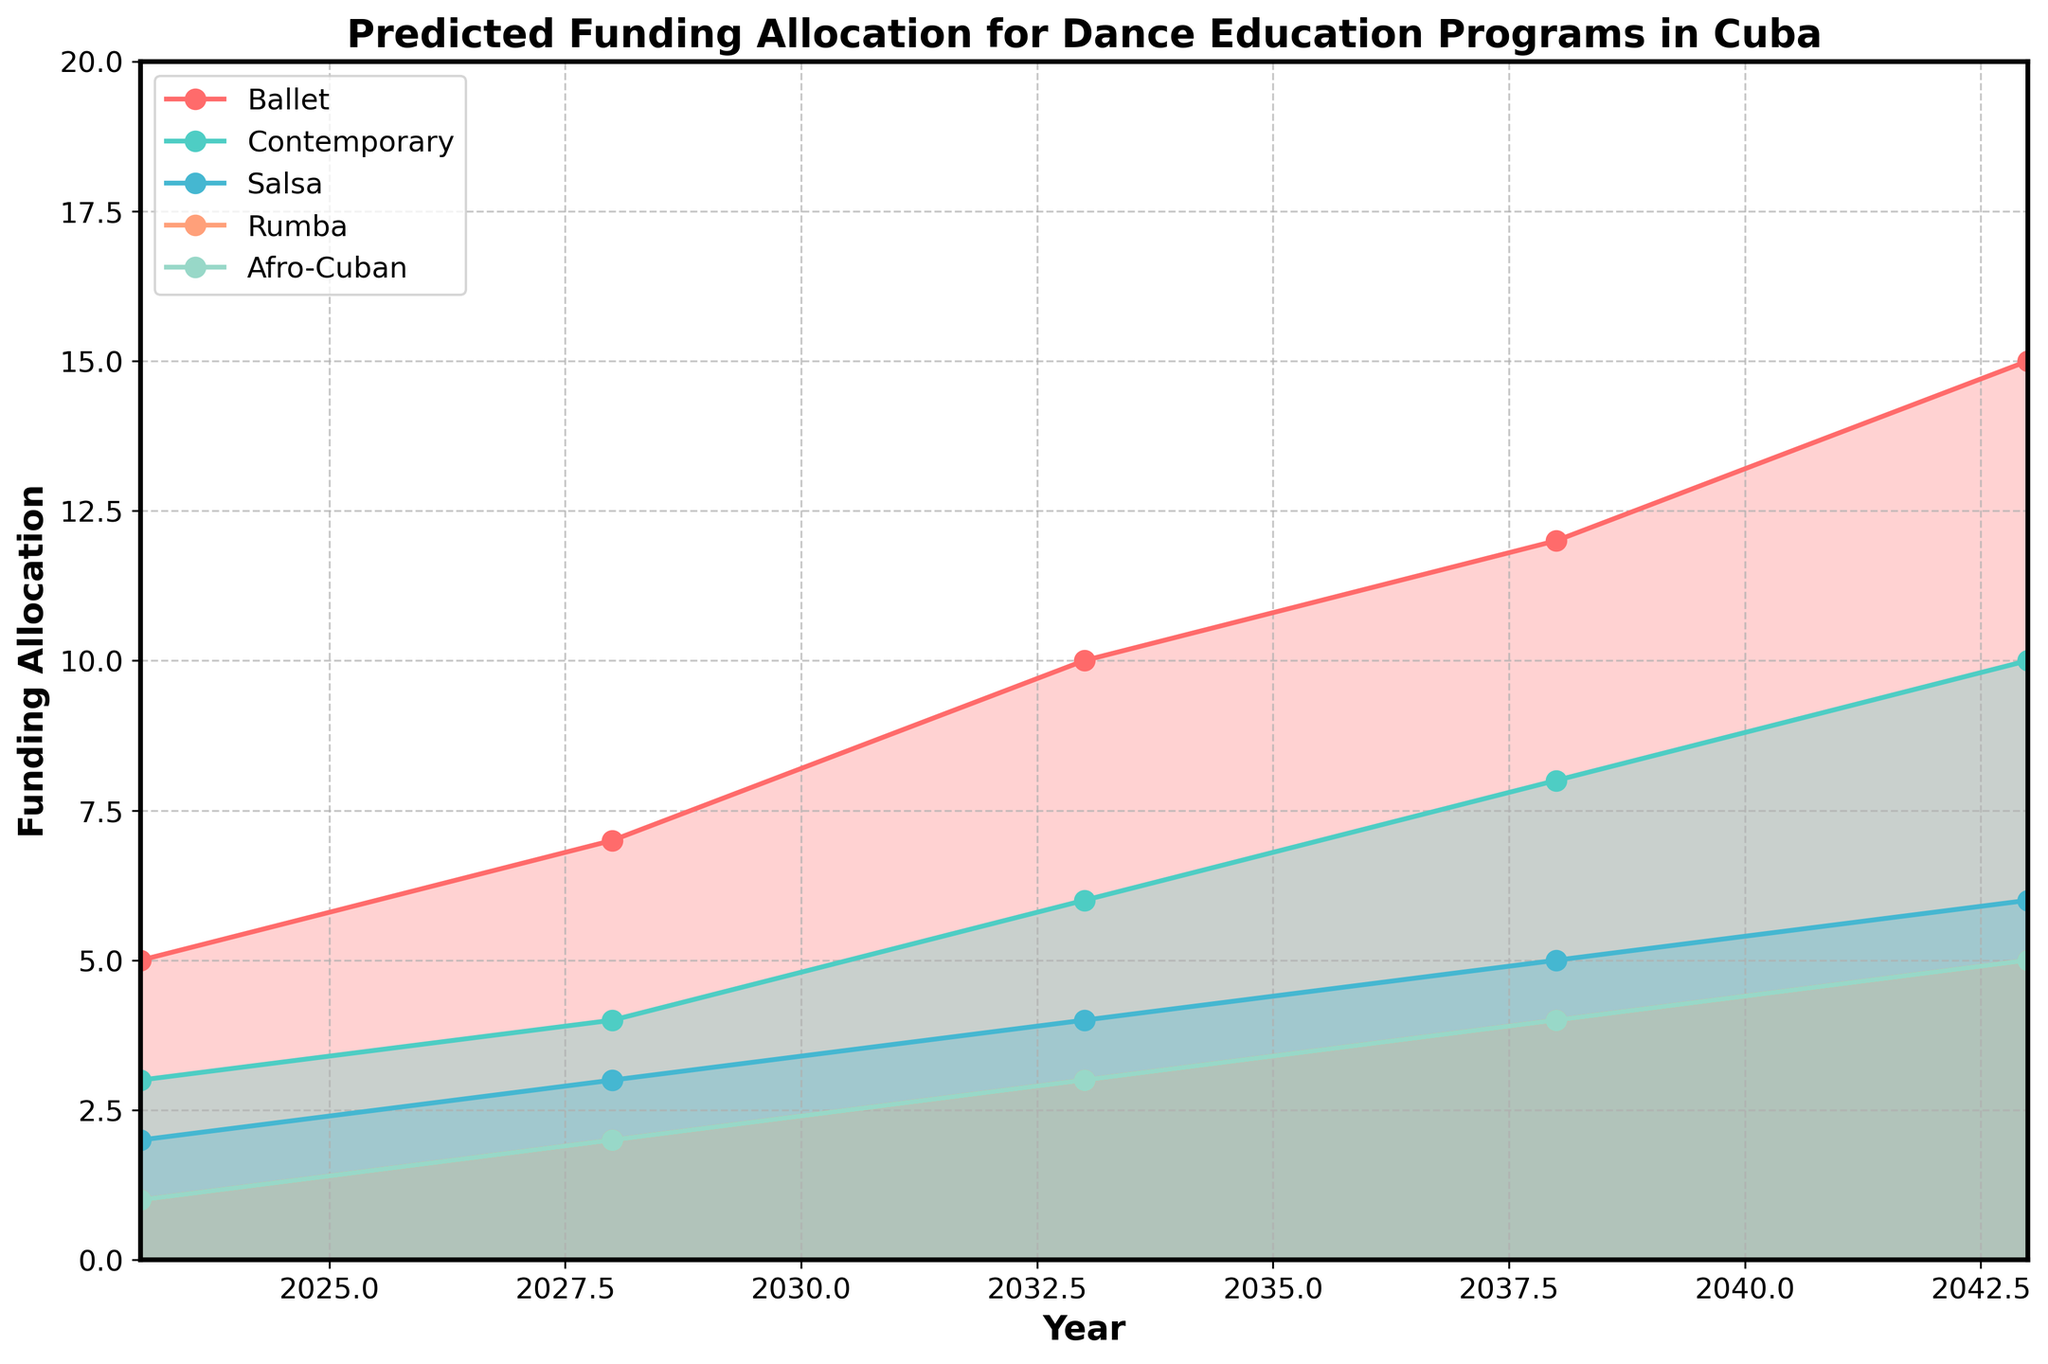What is the title of the figure? The title is usually displayed at the top of the figure. For this particular plot, the title should describe the content and focus of the chart.
Answer: Predicted Funding Allocation for Dance Education Programs in Cuba Which dance style shows the highest predicted funding in 2043? By looking at the endpoint for each line in the year 2043, we can determine which dance style has the highest value.
Answer: Ballet What is the predicted funding allocation for Afro-Cuban dance in the year 2033? To find the value, locate the year 2033 on the x-axis and follow the line corresponding to Afro-Cuban dance to the y-axis.
Answer: 3 How does the funding allocation for Contemporary dance in 2028 compare to Salsa in the same year? Find the values for Contemporary dance and Salsa in the year 2028. Contemporary is 4, Salsa is 3.
Answer: Contemporary receives more funding than Salsa Between which years does Afro-Cuban dance funding show the same incremental increase? To determine this, look at the values for Afro-Cuban dance over the years and notice the increment pattern.
Answer: Every 5 years (increases by 1) What is the average predicted funding allocation for Rumba between 2023 and 2043? Sum the predicted funding values for Rumba from 2023 to 2043 and divide by the number of data points. (1+2+3+4+5)/5 = 3
Answer: 3 Which dance style shows the most consistent growth trend over the 20 years? By examining the slope and increments of each line, the style with the most linear and steady increase is determined.
Answer: Ballet How much more funding is predicted for Ballet compared to Salsa in the year 2043? Find the values for Ballet and Salsa in 2043 and subtract Salsa's value from Ballet's value. 15 - 6 = 9
Answer: 9 Which two dance styles exhibit the closest predicted funding values in 2028? By comparing the values for each dance style in 2028, identify which two are closest in value.
Answer: Contemporary and Salsa What is the predicted total funding allocation for all dance styles combined in the year 2038? Add up the predicted funding values for each dance style for the year 2038. 12+8+5+4+4 = 33
Answer: 33 